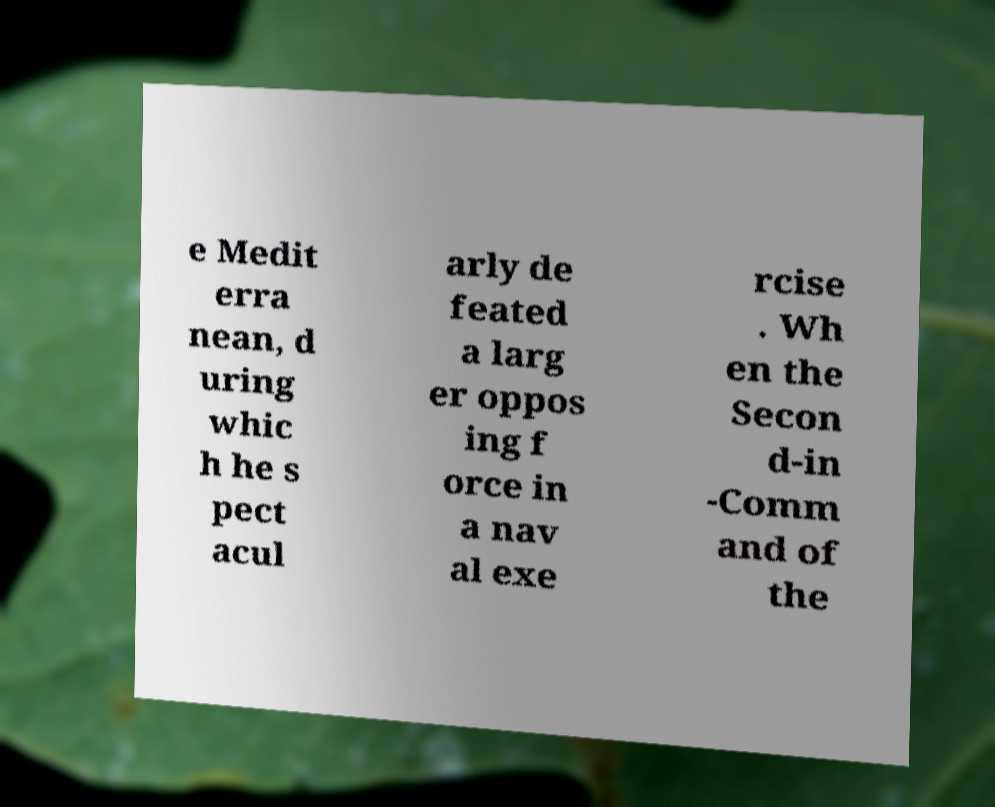I need the written content from this picture converted into text. Can you do that? e Medit erra nean, d uring whic h he s pect acul arly de feated a larg er oppos ing f orce in a nav al exe rcise . Wh en the Secon d-in -Comm and of the 